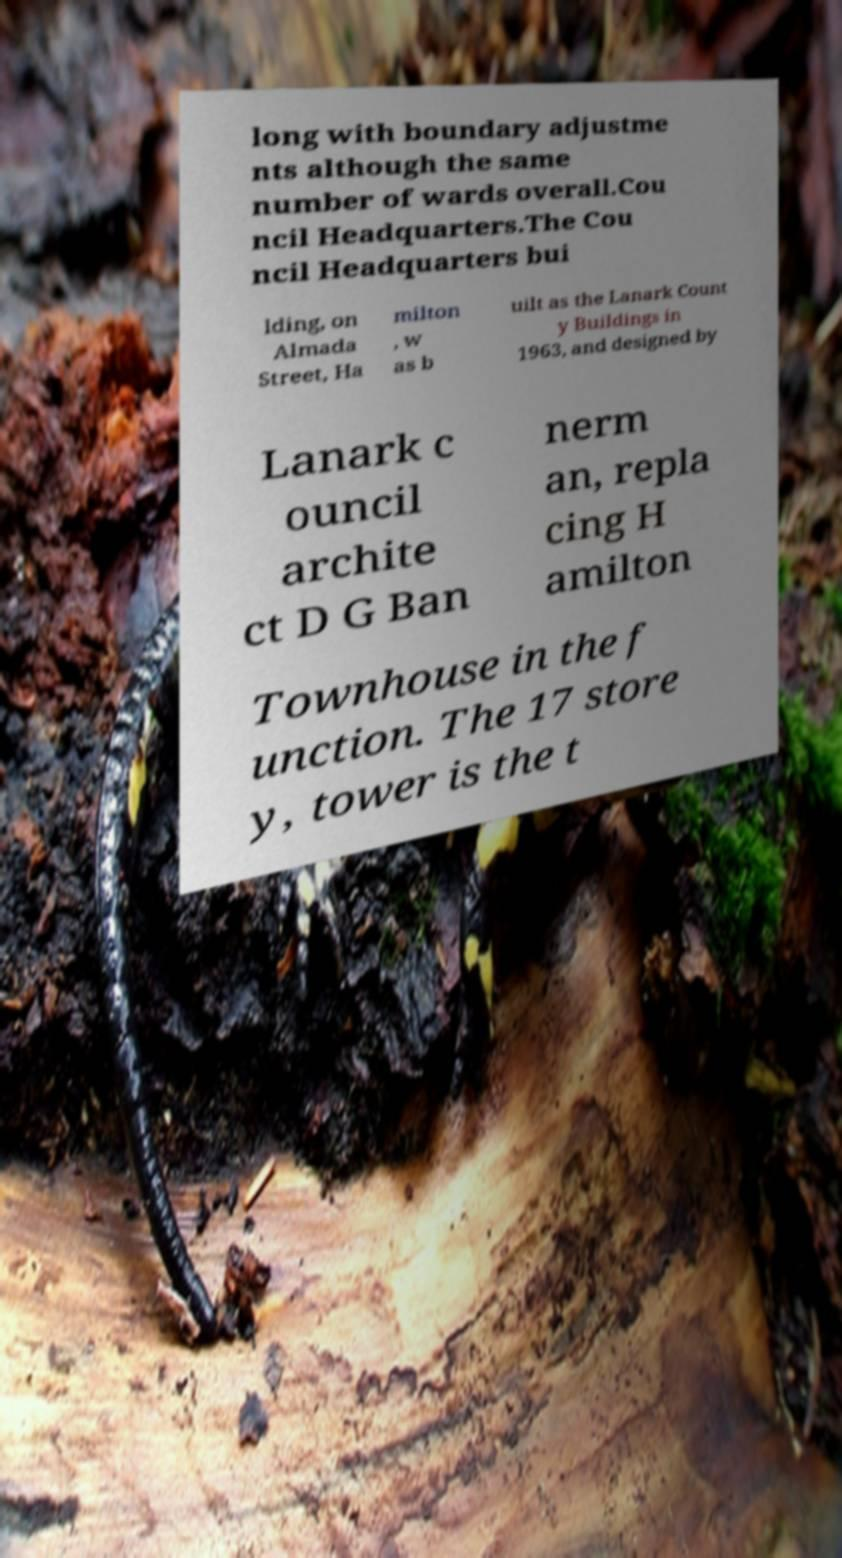Could you extract and type out the text from this image? long with boundary adjustme nts although the same number of wards overall.Cou ncil Headquarters.The Cou ncil Headquarters bui lding, on Almada Street, Ha milton , w as b uilt as the Lanark Count y Buildings in 1963, and designed by Lanark c ouncil archite ct D G Ban nerm an, repla cing H amilton Townhouse in the f unction. The 17 store y, tower is the t 